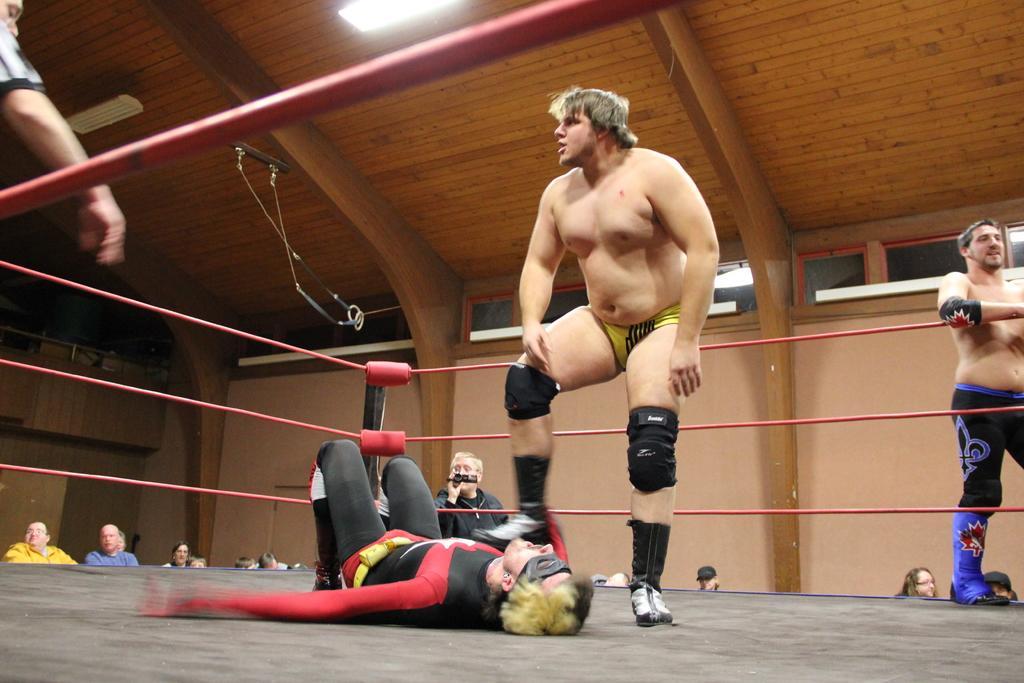Please provide a concise description of this image. In the picture I can see people among them some are on the stage. In the background I can see red color rope, lights on the ceiling, walls and some other objects. 